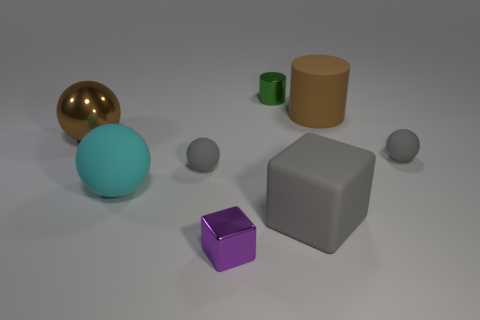Are there any other things that have the same color as the big metallic ball?
Keep it short and to the point. Yes. Is the tiny green object the same shape as the large brown matte thing?
Keep it short and to the point. Yes. There is a ball that is behind the small matte sphere that is to the right of the tiny ball to the left of the big matte cylinder; what size is it?
Give a very brief answer. Large. How many other things are the same material as the brown ball?
Your answer should be very brief. 2. What is the color of the small thing right of the big gray cube?
Offer a terse response. Gray. There is a tiny gray thing in front of the tiny sphere that is to the right of the metal thing in front of the cyan rubber ball; what is its material?
Keep it short and to the point. Rubber. Are there any cyan matte things of the same shape as the tiny green metal thing?
Make the answer very short. No. What is the shape of the cyan matte thing that is the same size as the gray cube?
Provide a succinct answer. Sphere. How many spheres are both on the right side of the purple cube and left of the big matte block?
Give a very brief answer. 0. Is the number of rubber things on the left side of the large cyan matte thing less than the number of tiny things?
Give a very brief answer. Yes. 